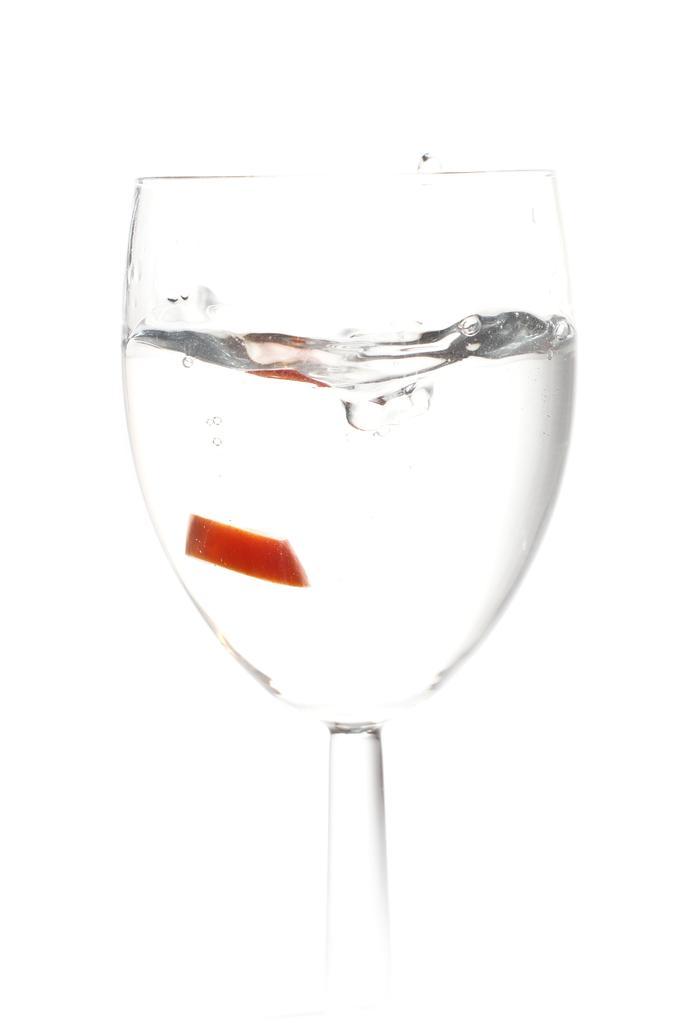Describe this image in one or two sentences. This picture shows a art. We see a glass with some liquid and a white color background. 